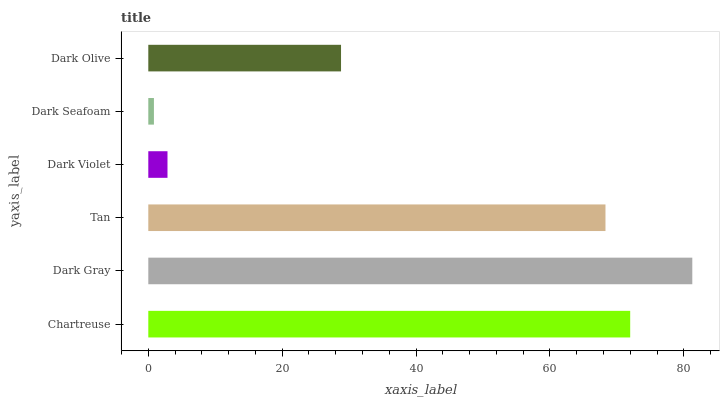Is Dark Seafoam the minimum?
Answer yes or no. Yes. Is Dark Gray the maximum?
Answer yes or no. Yes. Is Tan the minimum?
Answer yes or no. No. Is Tan the maximum?
Answer yes or no. No. Is Dark Gray greater than Tan?
Answer yes or no. Yes. Is Tan less than Dark Gray?
Answer yes or no. Yes. Is Tan greater than Dark Gray?
Answer yes or no. No. Is Dark Gray less than Tan?
Answer yes or no. No. Is Tan the high median?
Answer yes or no. Yes. Is Dark Olive the low median?
Answer yes or no. Yes. Is Dark Olive the high median?
Answer yes or no. No. Is Dark Seafoam the low median?
Answer yes or no. No. 